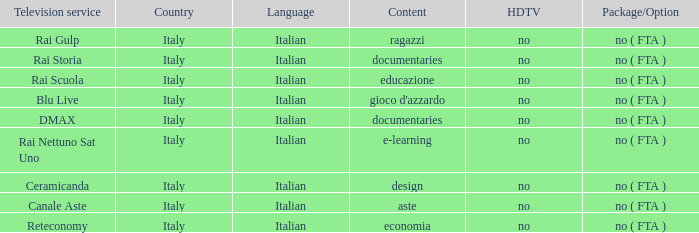What is the HDTV for the Rai Nettuno Sat Uno Television service? No. 